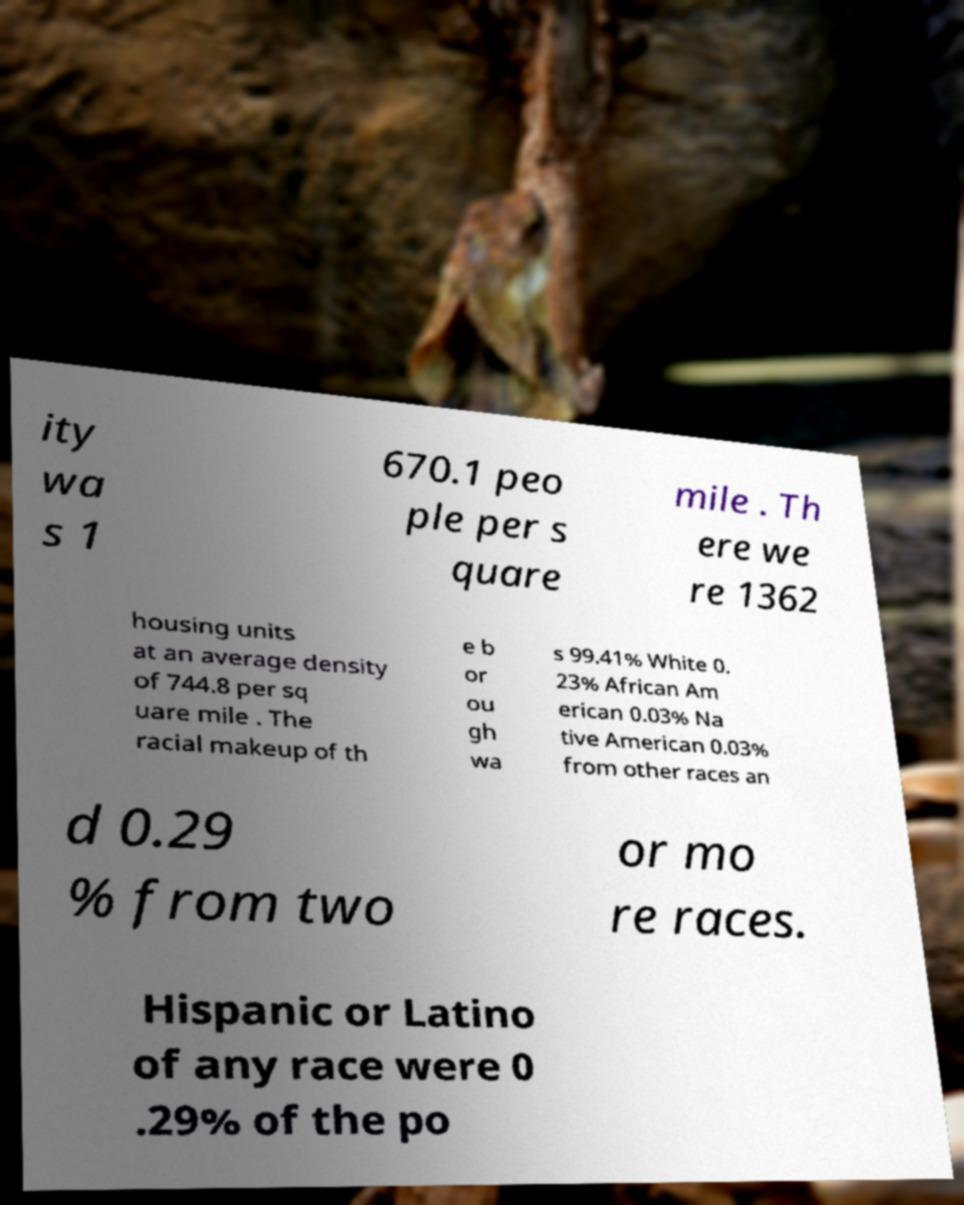Could you extract and type out the text from this image? ity wa s 1 670.1 peo ple per s quare mile . Th ere we re 1362 housing units at an average density of 744.8 per sq uare mile . The racial makeup of th e b or ou gh wa s 99.41% White 0. 23% African Am erican 0.03% Na tive American 0.03% from other races an d 0.29 % from two or mo re races. Hispanic or Latino of any race were 0 .29% of the po 